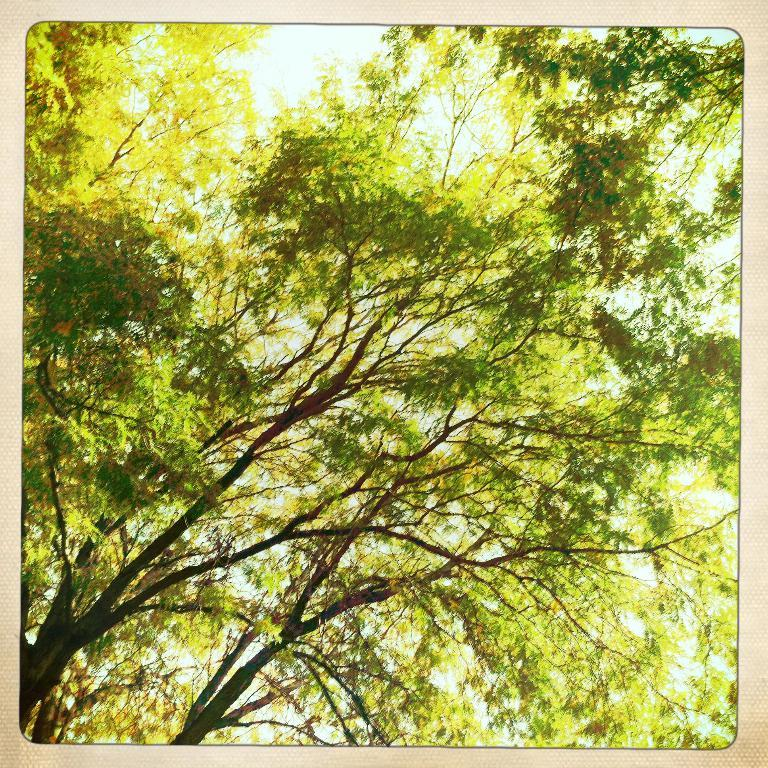What object is present in the image that typically holds a photograph? There is a photo frame in the image. What is depicted in the photo frame? The photo frame contains an image of trees. What can be seen in the background of the image? There is sky visible in the background of the image. What is the interest rate on the loan depicted in the image? There is no loan or interest rate mentioned in the image; it features a photo frame with an image of trees and a visible sky in the background. 